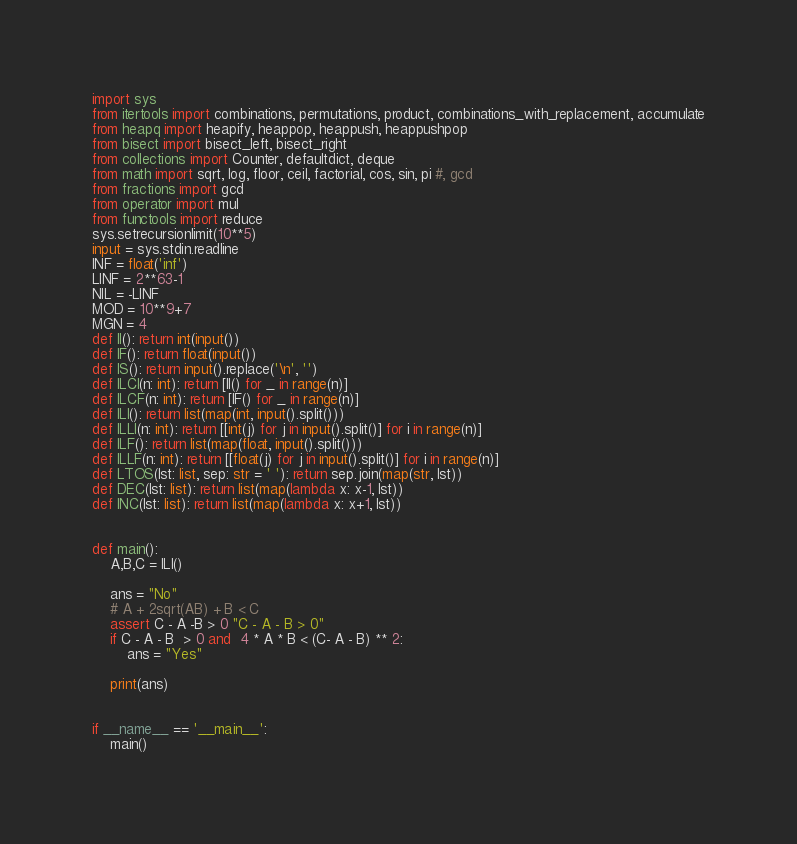<code> <loc_0><loc_0><loc_500><loc_500><_Python_>import sys
from itertools import combinations, permutations, product, combinations_with_replacement, accumulate
from heapq import heapify, heappop, heappush, heappushpop
from bisect import bisect_left, bisect_right
from collections import Counter, defaultdict, deque
from math import sqrt, log, floor, ceil, factorial, cos, sin, pi #, gcd
from fractions import gcd
from operator import mul
from functools import reduce
sys.setrecursionlimit(10**5)
input = sys.stdin.readline
INF = float('inf')
LINF = 2**63-1
NIL = -LINF
MOD = 10**9+7
MGN = 4
def II(): return int(input())
def IF(): return float(input())
def IS(): return input().replace('\n', '')
def ILCI(n: int): return [II() for _ in range(n)]
def ILCF(n: int): return [IF() for _ in range(n)]
def ILI(): return list(map(int, input().split()))
def ILLI(n: int): return [[int(j) for j in input().split()] for i in range(n)]
def ILF(): return list(map(float, input().split()))
def ILLF(n: int): return [[float(j) for j in input().split()] for i in range(n)]
def LTOS(lst: list, sep: str = ' '): return sep.join(map(str, lst))
def DEC(lst: list): return list(map(lambda x: x-1, lst))
def INC(lst: list): return list(map(lambda x: x+1, lst))


def main():
    A,B,C = ILI()

    ans = "No"
    # A + 2sqrt(AB) + B < C
    assert C - A -B > 0 "C - A - B > 0"
    if C - A - B  > 0 and  4 * A * B < (C- A - B) ** 2:
        ans = "Yes"

    print(ans)


if __name__ == '__main__':
    main()
</code> 